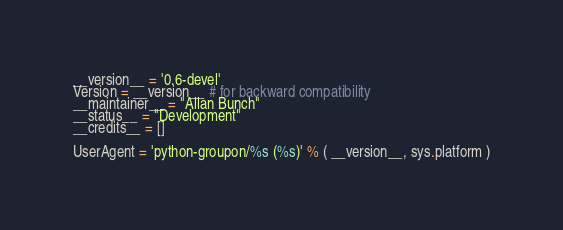Convert code to text. <code><loc_0><loc_0><loc_500><loc_500><_Python_>__version__ = '0.6-devel'
Version = __version__ # for backward compatibility
__maintainer__ = "Allan Bunch"
__status__ = "Development"
__credits__ = []

UserAgent = 'python-groupon/%s (%s)' % ( __version__, sys.platform )
</code> 